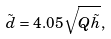Convert formula to latex. <formula><loc_0><loc_0><loc_500><loc_500>\tilde { d } = 4 . 0 5 \sqrt { Q \tilde { h } } ,</formula> 